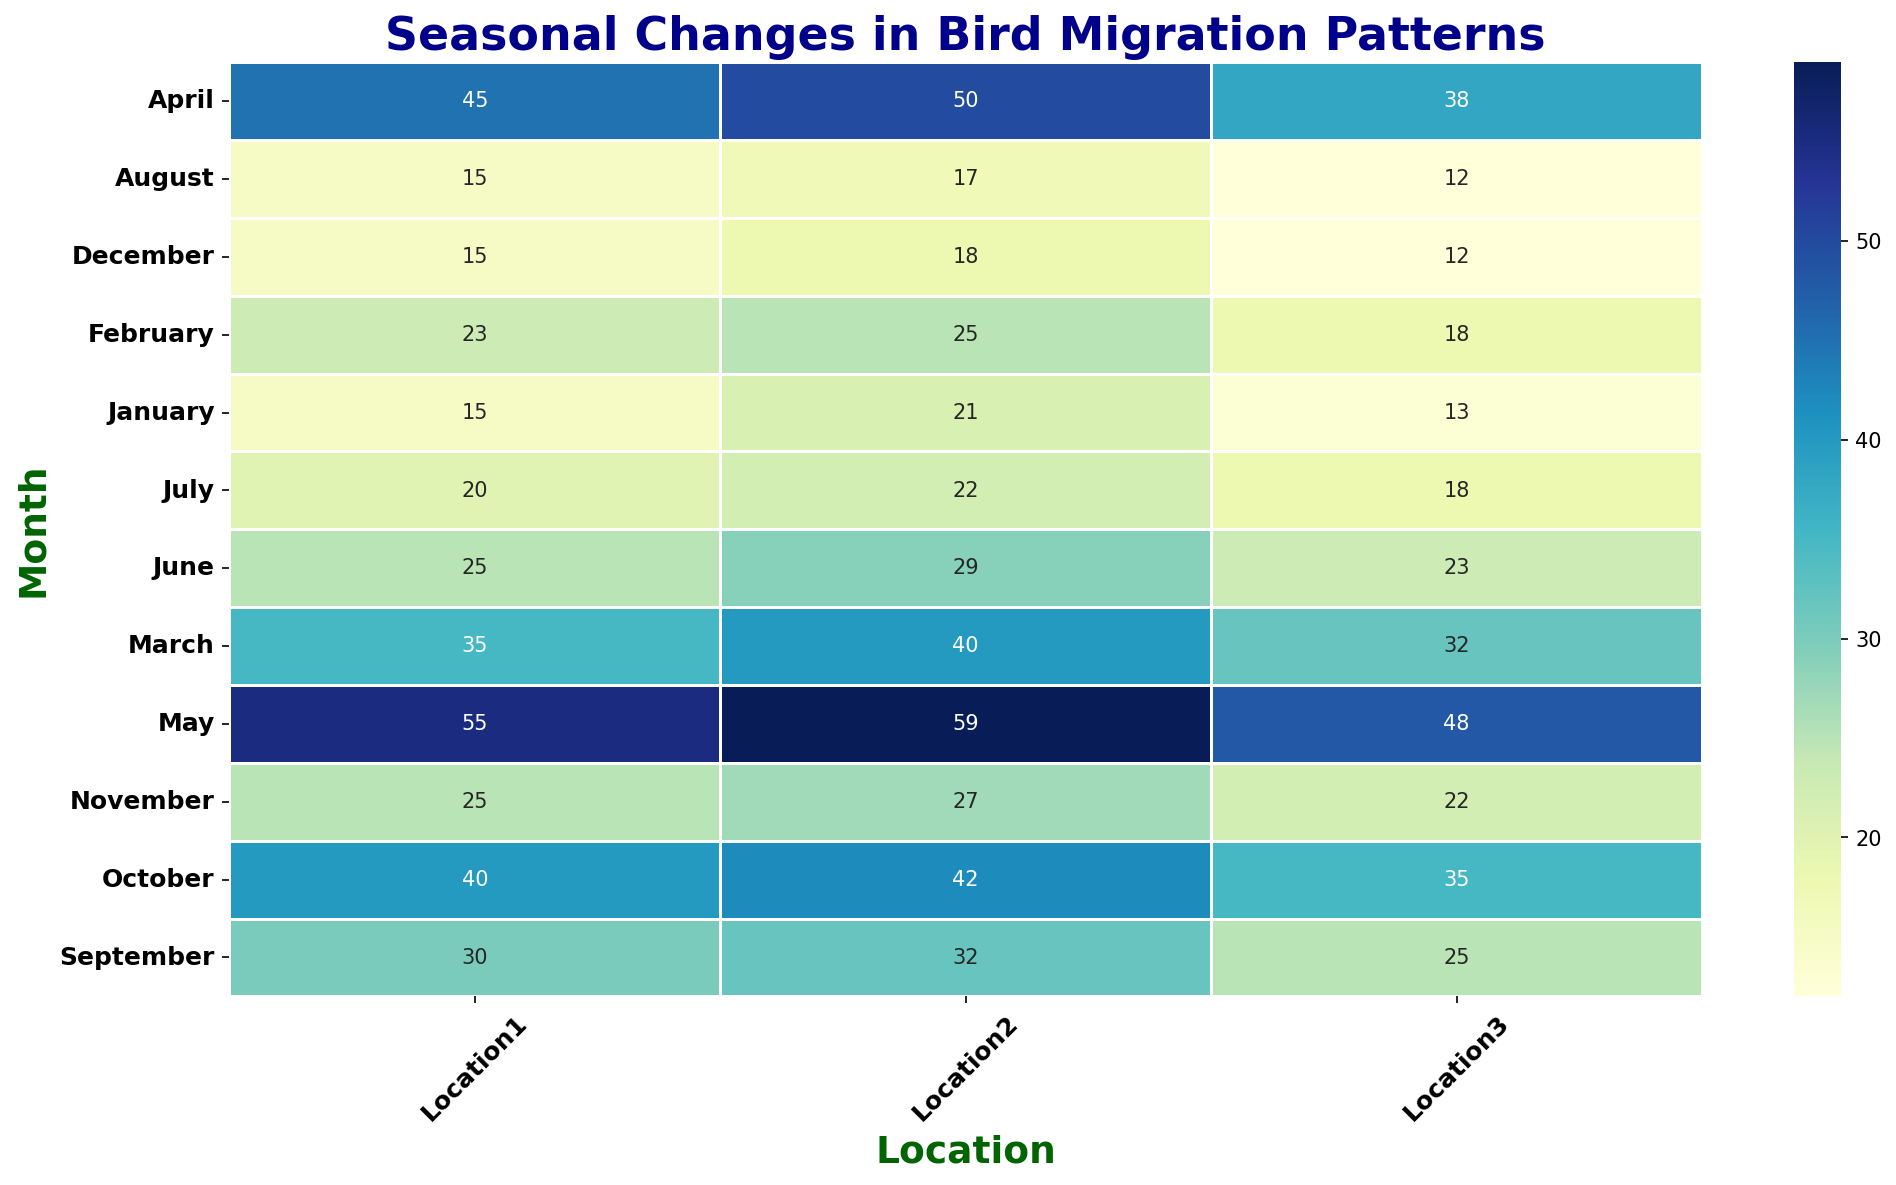Which month has the highest number of bird sightings at Location1? Look for the cell in the heatmap for Location1 with the highest value. The darkest color will also indicate the highest number of sightings. April for Location1 has the highest value of bird sightings, which is 45.
Answer: April Which location has the highest number of bird sightings in May? Identify the May row in the heatmap and compare the values across the three locations. The color intensity can help quickly identify the highest value. Location2 has the highest number in May with 59 total sightings.
Answer: Location2 How do bird sightings at Location3 in March compare to Location1 in March? Find the values for March for both Location3 and Location1. In March, Location3 has a total of 32 sightings while Location1 has a combined value of 35 sightings. Compare these numbers to determine that Location1 has more sightings than Location3 in March.
Answer: Location1 has more sightings Which month shows the most consistent bird sightings across all three locations? Consistency can be gauged by looking for the month where all three locations have similar values. Compare the values row by row. June shows values that are relatively close in number across all three locations: 26 in total at Location1, 29 in total at Location2, and 23 in total at Location 3.
Answer: June In which location and month do bird sightings drop significantly after a peak? Look for a location where a high value in one month is followed by a noticeably lower value in the subsequent month. For example, at Location1, May has 55 sightings, then drops to 25 in June. Identify the steepest drop.
Answer: Location1, June What is the average number of bird sightings in October across all locations? Sum the bird sightings for October across the three locations and divide by the number of locations. The total number of sightings in October is 59 at Location1, Location2, and Location3. Dividing 59 by 3 gives an average of 29.67.
Answer: 29.67 Is there a trend in bird sightings at Location2 from March to September? Identify the values from March to September for Location2 and observe any increase or decrease. The total sightings increase from 40 (March) to 22 (April), then increases to 59 (May), decreases to 26 (June), decreases to 22 (July), decreases to 17 (August), and increases to 32 (September). The trend is initially an increase, followed by a decrease, and then an increase again.
Answer: Fluctuating trend Which location tends to have the highest bird sightings consistently across spring (March to May)? Sum the sightings for the months of March, April, and May for each location. Compare which location has the highest total value. For Location1: March (35) + April (45) + May (55) = 135. For Location2: March (40) + April (50) + May (59) = 149. For Location3: March (32) + April (38) + May (48) = 118. Location2 consistently has the highest sightings.
Answer: Location2 By how much do the bird sightings for SpeciesA and SpeciesB combined in July differ between Location1 and Location2? Find the values for the total sightings in July for both locations and calculate the difference. For Location1: July = 20. For Location2: July = 22. The difference is
Answer: 2 